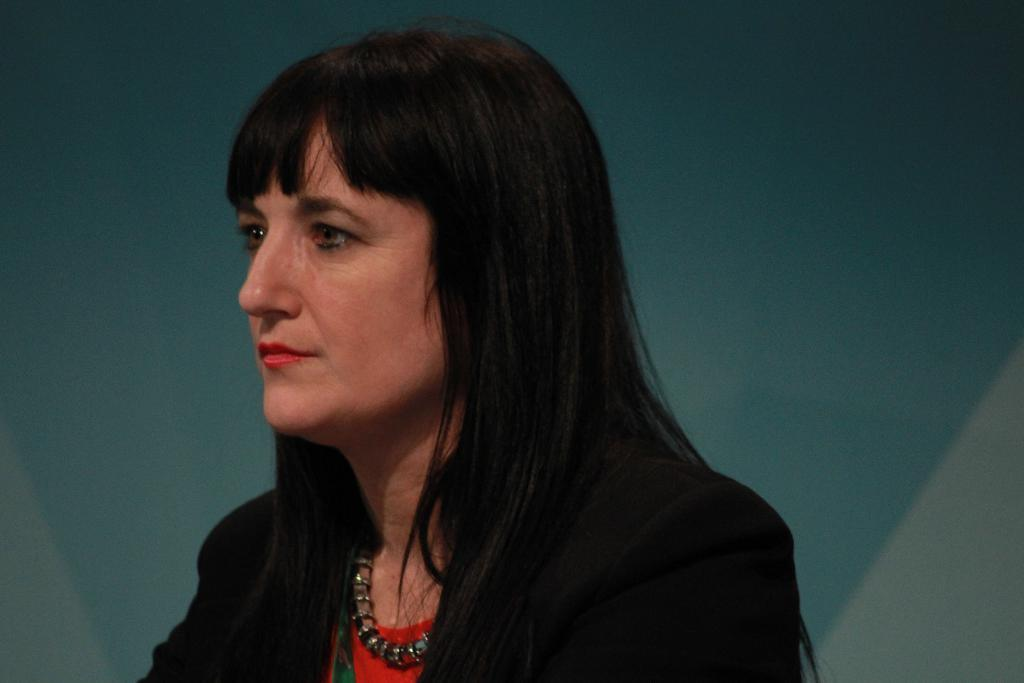Who is present in the image? There is a woman in the image. What is the woman wearing? The woman is wearing a black and red color dress. Are there any accessories visible on the woman? Yes, the woman is wearing a necklace. What colors are present in the background of the image? The background of the image is white and blue. What type of brush is the woman using to prepare a feast in the image? There is no brush or feast present in the image; it features a woman wearing a black and red dress with a necklace. 